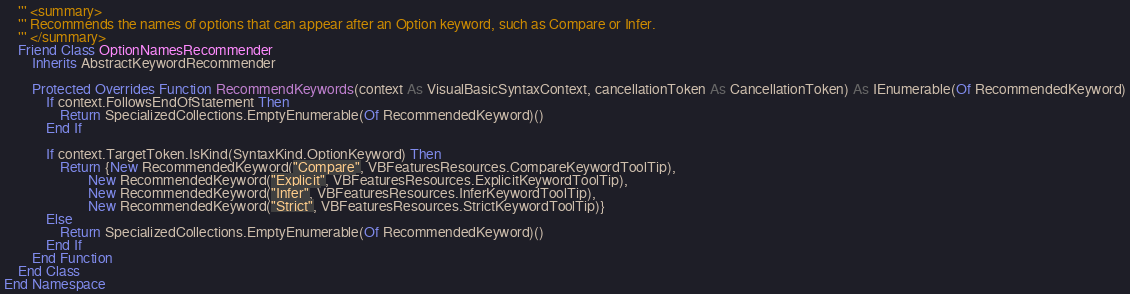Convert code to text. <code><loc_0><loc_0><loc_500><loc_500><_VisualBasic_>    ''' <summary>
    ''' Recommends the names of options that can appear after an Option keyword, such as Compare or Infer.
    ''' </summary>
    Friend Class OptionNamesRecommender
        Inherits AbstractKeywordRecommender

        Protected Overrides Function RecommendKeywords(context As VisualBasicSyntaxContext, cancellationToken As CancellationToken) As IEnumerable(Of RecommendedKeyword)
            If context.FollowsEndOfStatement Then
                Return SpecializedCollections.EmptyEnumerable(Of RecommendedKeyword)()
            End If

            If context.TargetToken.IsKind(SyntaxKind.OptionKeyword) Then
                Return {New RecommendedKeyword("Compare", VBFeaturesResources.CompareKeywordToolTip),
                        New RecommendedKeyword("Explicit", VBFeaturesResources.ExplicitKeywordToolTip),
                        New RecommendedKeyword("Infer", VBFeaturesResources.InferKeywordToolTip),
                        New RecommendedKeyword("Strict", VBFeaturesResources.StrictKeywordToolTip)}
            Else
                Return SpecializedCollections.EmptyEnumerable(Of RecommendedKeyword)()
            End If
        End Function
    End Class
End Namespace
</code> 